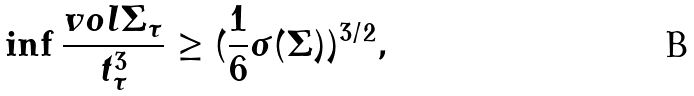Convert formula to latex. <formula><loc_0><loc_0><loc_500><loc_500>\inf \frac { v o l \Sigma _ { \tau } } { t _ { \tau } ^ { 3 } } \geq ( \frac { 1 } { 6 } \sigma ( \Sigma ) ) ^ { 3 / 2 } ,</formula> 